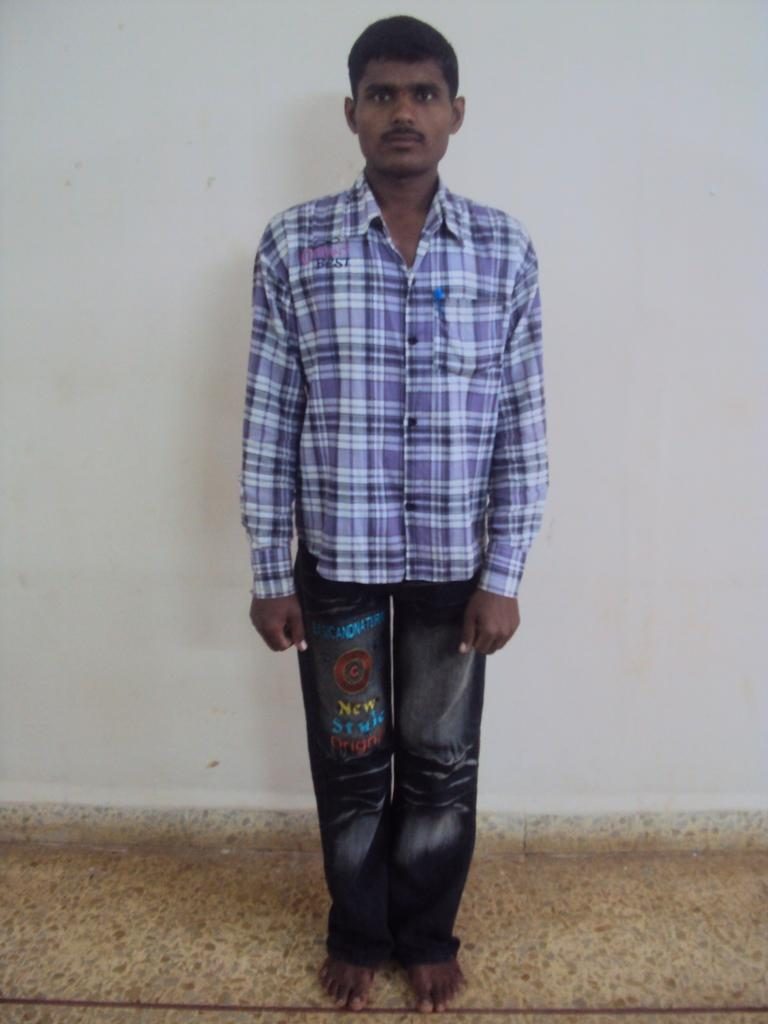Who is present in the image? There is a man in the image. What is the man wearing on his upper body? The man is wearing a blue shirt. What type of pants is the man wearing? The man is wearing jeans. What can be seen beneath the man's feet? There is a floor visible in the image. What is visible behind the man? There is a wall in the background of the image. What type of button can be seen on the man's shirt in the image? There is no button visible on the man's shirt in the image; it is a blue shirt without any visible buttons. 